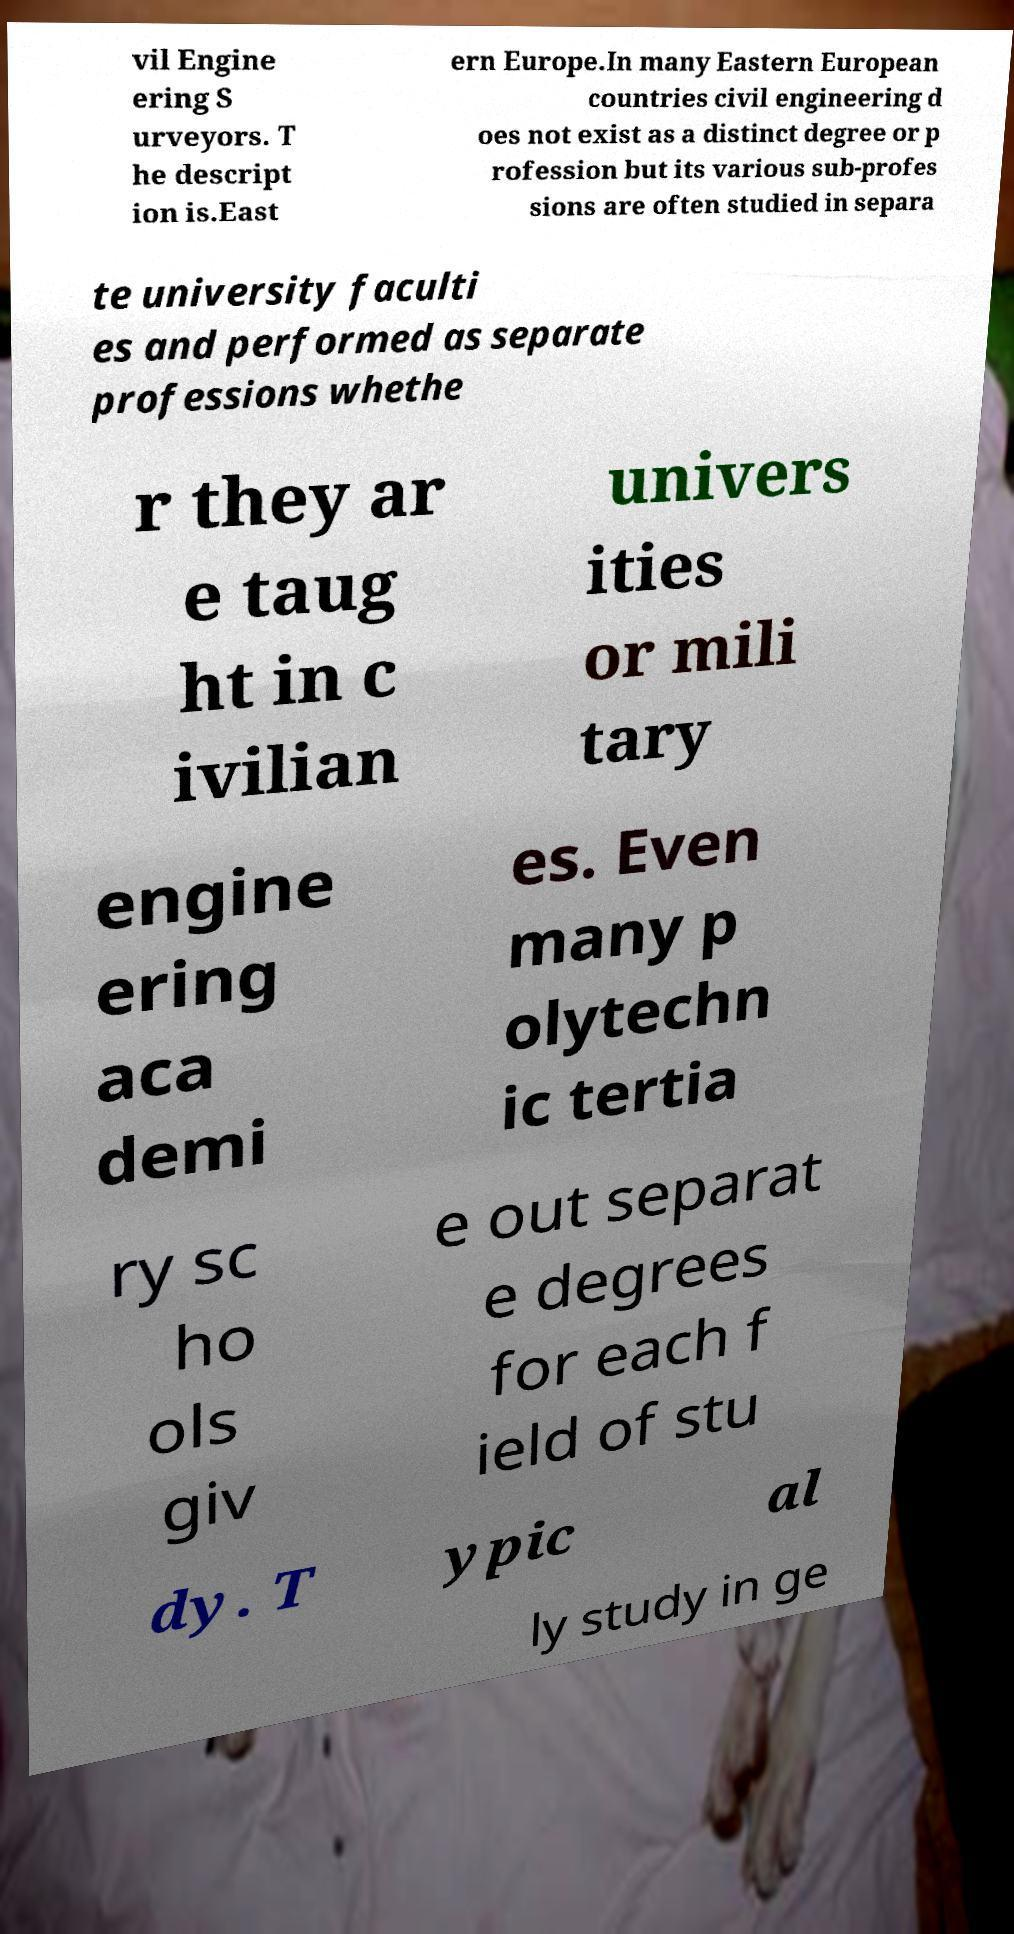Please identify and transcribe the text found in this image. vil Engine ering S urveyors. T he descript ion is.East ern Europe.In many Eastern European countries civil engineering d oes not exist as a distinct degree or p rofession but its various sub-profes sions are often studied in separa te university faculti es and performed as separate professions whethe r they ar e taug ht in c ivilian univers ities or mili tary engine ering aca demi es. Even many p olytechn ic tertia ry sc ho ols giv e out separat e degrees for each f ield of stu dy. T ypic al ly study in ge 